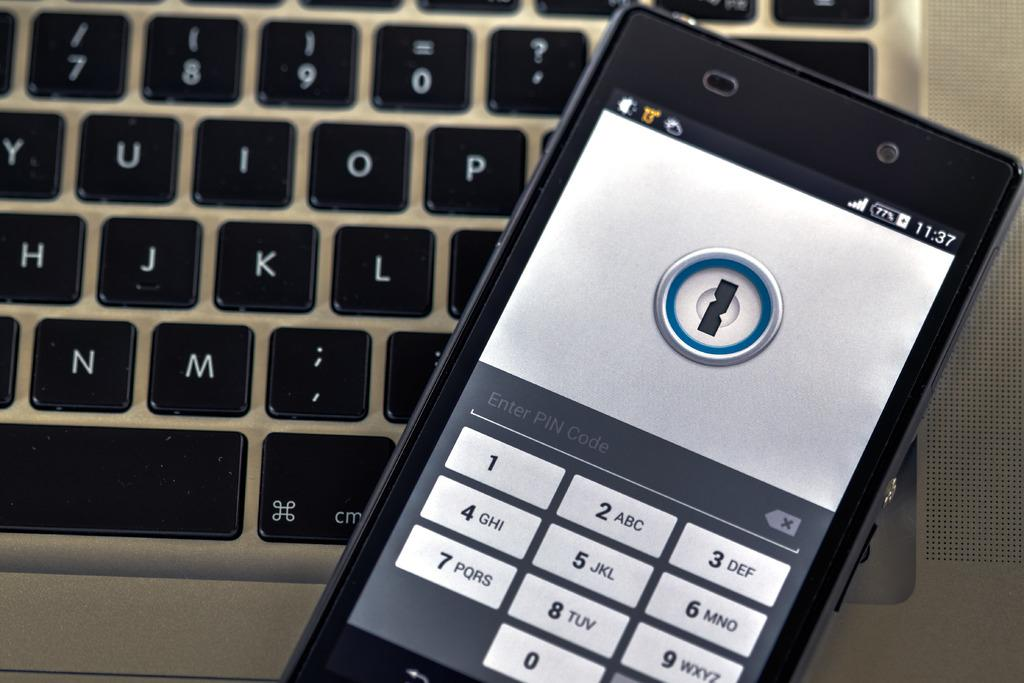<image>
Relay a brief, clear account of the picture shown. a phone with the time of 11:37 shown on it 